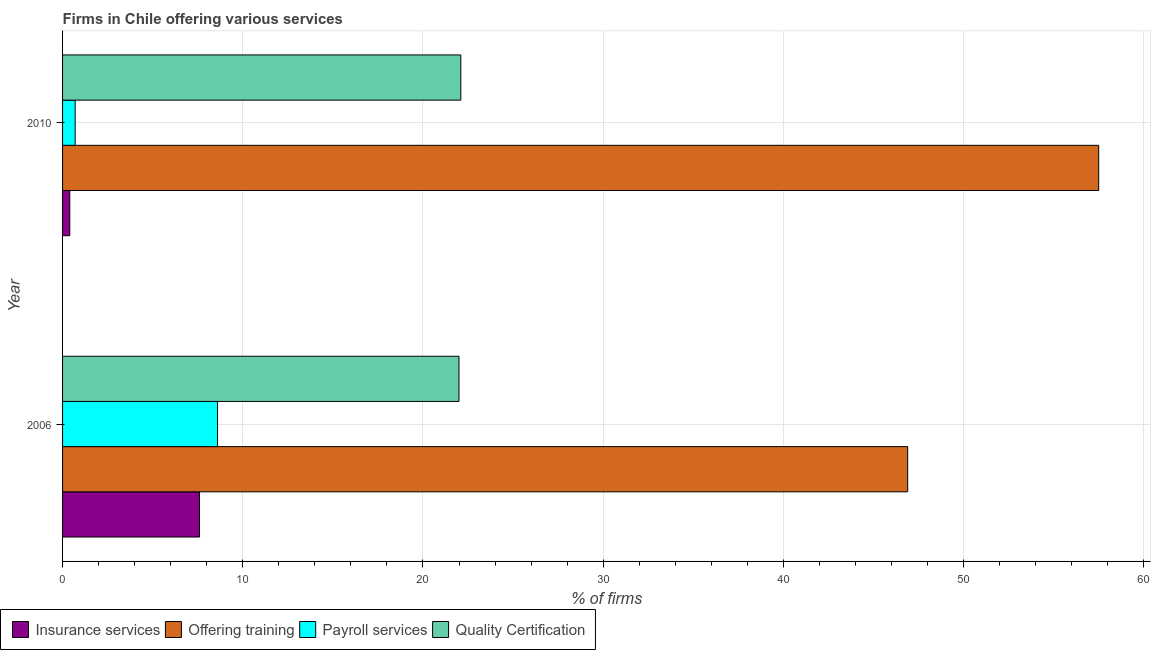How many different coloured bars are there?
Give a very brief answer. 4. How many groups of bars are there?
Offer a very short reply. 2. Are the number of bars on each tick of the Y-axis equal?
Make the answer very short. Yes. How many bars are there on the 1st tick from the bottom?
Keep it short and to the point. 4. What is the percentage of firms offering insurance services in 2006?
Offer a very short reply. 7.6. Across all years, what is the maximum percentage of firms offering payroll services?
Offer a very short reply. 8.6. In which year was the percentage of firms offering quality certification maximum?
Ensure brevity in your answer.  2010. What is the difference between the percentage of firms offering insurance services in 2006 and that in 2010?
Offer a very short reply. 7.2. What is the difference between the percentage of firms offering payroll services in 2010 and the percentage of firms offering training in 2006?
Offer a terse response. -46.2. What is the average percentage of firms offering quality certification per year?
Make the answer very short. 22.05. In the year 2006, what is the difference between the percentage of firms offering payroll services and percentage of firms offering training?
Make the answer very short. -38.3. What is the ratio of the percentage of firms offering payroll services in 2006 to that in 2010?
Your answer should be compact. 12.29. What does the 4th bar from the top in 2010 represents?
Offer a very short reply. Insurance services. What does the 2nd bar from the bottom in 2006 represents?
Your response must be concise. Offering training. Is it the case that in every year, the sum of the percentage of firms offering insurance services and percentage of firms offering training is greater than the percentage of firms offering payroll services?
Provide a short and direct response. Yes. Are all the bars in the graph horizontal?
Your answer should be very brief. Yes. How many years are there in the graph?
Your answer should be very brief. 2. What is the difference between two consecutive major ticks on the X-axis?
Make the answer very short. 10. Does the graph contain any zero values?
Provide a succinct answer. No. Where does the legend appear in the graph?
Ensure brevity in your answer.  Bottom left. How are the legend labels stacked?
Give a very brief answer. Horizontal. What is the title of the graph?
Your answer should be very brief. Firms in Chile offering various services . Does "Agriculture" appear as one of the legend labels in the graph?
Your response must be concise. No. What is the label or title of the X-axis?
Make the answer very short. % of firms. What is the label or title of the Y-axis?
Offer a very short reply. Year. What is the % of firms in Offering training in 2006?
Your answer should be compact. 46.9. What is the % of firms of Quality Certification in 2006?
Provide a succinct answer. 22. What is the % of firms in Offering training in 2010?
Offer a very short reply. 57.5. What is the % of firms in Quality Certification in 2010?
Keep it short and to the point. 22.1. Across all years, what is the maximum % of firms of Insurance services?
Offer a very short reply. 7.6. Across all years, what is the maximum % of firms of Offering training?
Give a very brief answer. 57.5. Across all years, what is the maximum % of firms in Payroll services?
Ensure brevity in your answer.  8.6. Across all years, what is the maximum % of firms of Quality Certification?
Ensure brevity in your answer.  22.1. Across all years, what is the minimum % of firms in Insurance services?
Keep it short and to the point. 0.4. Across all years, what is the minimum % of firms in Offering training?
Give a very brief answer. 46.9. Across all years, what is the minimum % of firms in Quality Certification?
Give a very brief answer. 22. What is the total % of firms in Insurance services in the graph?
Make the answer very short. 8. What is the total % of firms in Offering training in the graph?
Offer a terse response. 104.4. What is the total % of firms in Payroll services in the graph?
Your answer should be compact. 9.3. What is the total % of firms of Quality Certification in the graph?
Give a very brief answer. 44.1. What is the difference between the % of firms in Insurance services in 2006 and that in 2010?
Your answer should be compact. 7.2. What is the difference between the % of firms in Quality Certification in 2006 and that in 2010?
Keep it short and to the point. -0.1. What is the difference between the % of firms of Insurance services in 2006 and the % of firms of Offering training in 2010?
Ensure brevity in your answer.  -49.9. What is the difference between the % of firms of Insurance services in 2006 and the % of firms of Quality Certification in 2010?
Your answer should be compact. -14.5. What is the difference between the % of firms of Offering training in 2006 and the % of firms of Payroll services in 2010?
Give a very brief answer. 46.2. What is the difference between the % of firms of Offering training in 2006 and the % of firms of Quality Certification in 2010?
Ensure brevity in your answer.  24.8. What is the average % of firms in Insurance services per year?
Provide a short and direct response. 4. What is the average % of firms of Offering training per year?
Your answer should be very brief. 52.2. What is the average % of firms of Payroll services per year?
Keep it short and to the point. 4.65. What is the average % of firms of Quality Certification per year?
Offer a very short reply. 22.05. In the year 2006, what is the difference between the % of firms of Insurance services and % of firms of Offering training?
Provide a short and direct response. -39.3. In the year 2006, what is the difference between the % of firms of Insurance services and % of firms of Payroll services?
Make the answer very short. -1. In the year 2006, what is the difference between the % of firms of Insurance services and % of firms of Quality Certification?
Ensure brevity in your answer.  -14.4. In the year 2006, what is the difference between the % of firms of Offering training and % of firms of Payroll services?
Keep it short and to the point. 38.3. In the year 2006, what is the difference between the % of firms of Offering training and % of firms of Quality Certification?
Make the answer very short. 24.9. In the year 2010, what is the difference between the % of firms in Insurance services and % of firms in Offering training?
Your answer should be very brief. -57.1. In the year 2010, what is the difference between the % of firms in Insurance services and % of firms in Quality Certification?
Ensure brevity in your answer.  -21.7. In the year 2010, what is the difference between the % of firms in Offering training and % of firms in Payroll services?
Provide a short and direct response. 56.8. In the year 2010, what is the difference between the % of firms of Offering training and % of firms of Quality Certification?
Your answer should be compact. 35.4. In the year 2010, what is the difference between the % of firms of Payroll services and % of firms of Quality Certification?
Keep it short and to the point. -21.4. What is the ratio of the % of firms in Insurance services in 2006 to that in 2010?
Make the answer very short. 19. What is the ratio of the % of firms in Offering training in 2006 to that in 2010?
Give a very brief answer. 0.82. What is the ratio of the % of firms of Payroll services in 2006 to that in 2010?
Provide a short and direct response. 12.29. What is the difference between the highest and the second highest % of firms of Insurance services?
Provide a succinct answer. 7.2. What is the difference between the highest and the lowest % of firms of Offering training?
Provide a succinct answer. 10.6. 